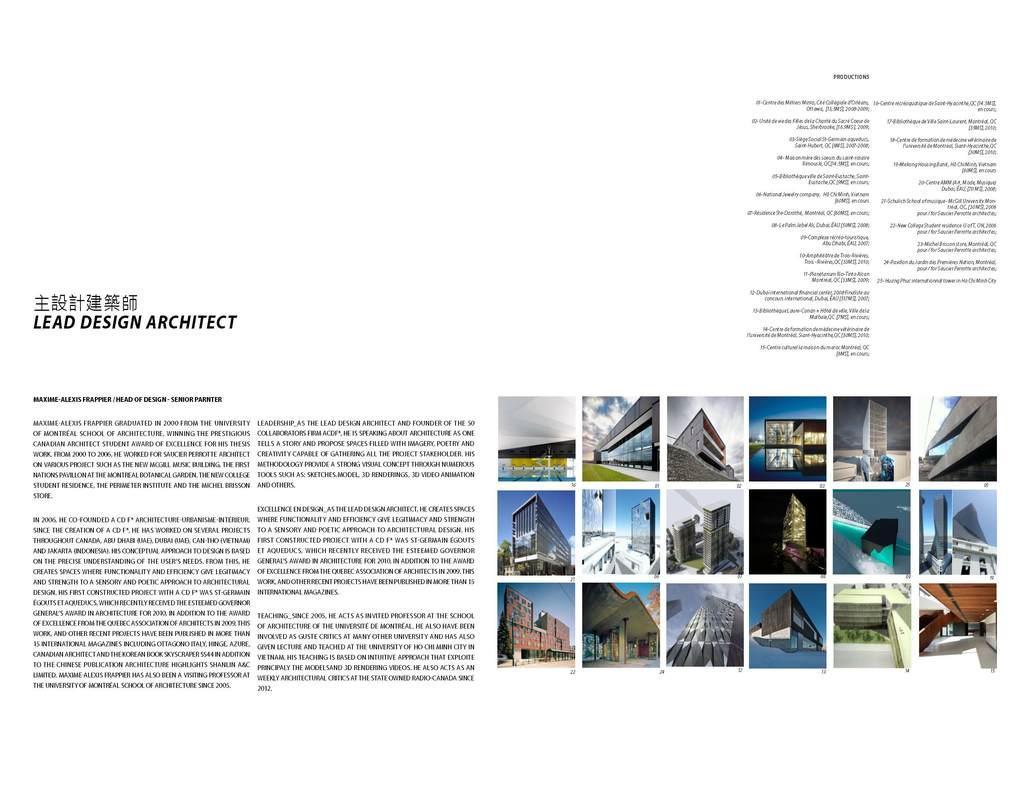Can you describe this image briefly? In the picture we can see a magazine with some information about lead space architect and beside it, we can see some photos of different type of buildings. 